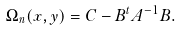<formula> <loc_0><loc_0><loc_500><loc_500>\Omega _ { n } ( x , y ) = C - B ^ { t } A ^ { - 1 } B .</formula> 